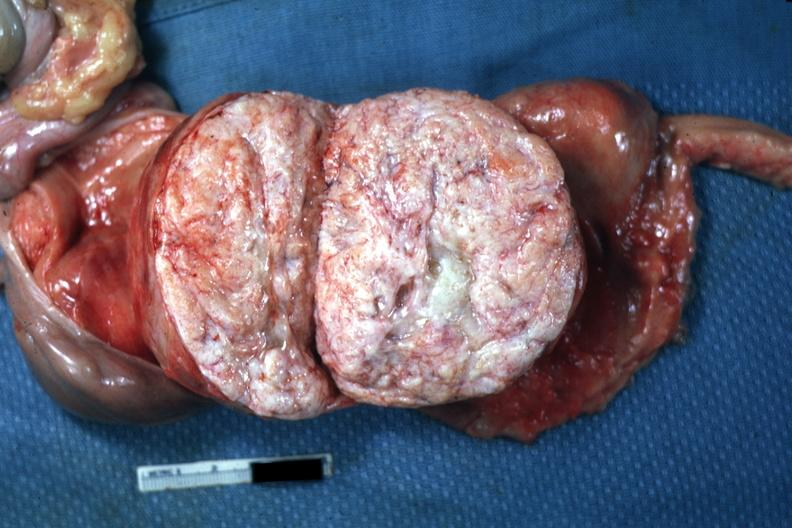what is present?
Answer the question using a single word or phrase. Female reproductive 